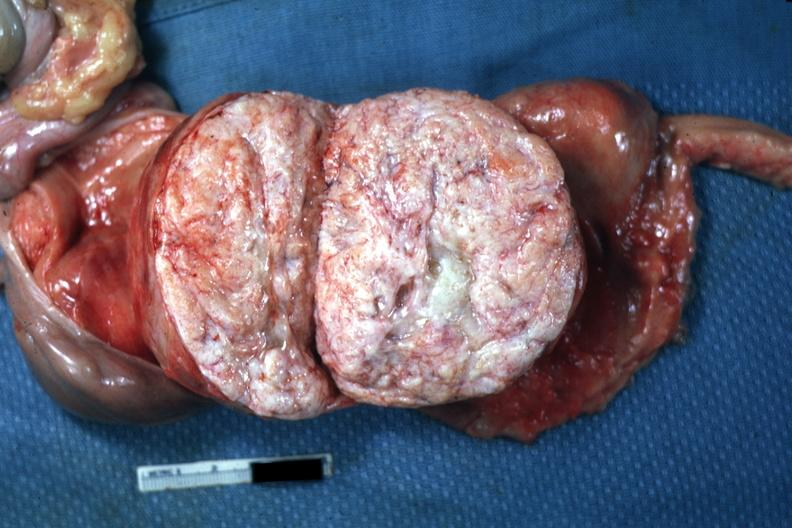what is present?
Answer the question using a single word or phrase. Female reproductive 